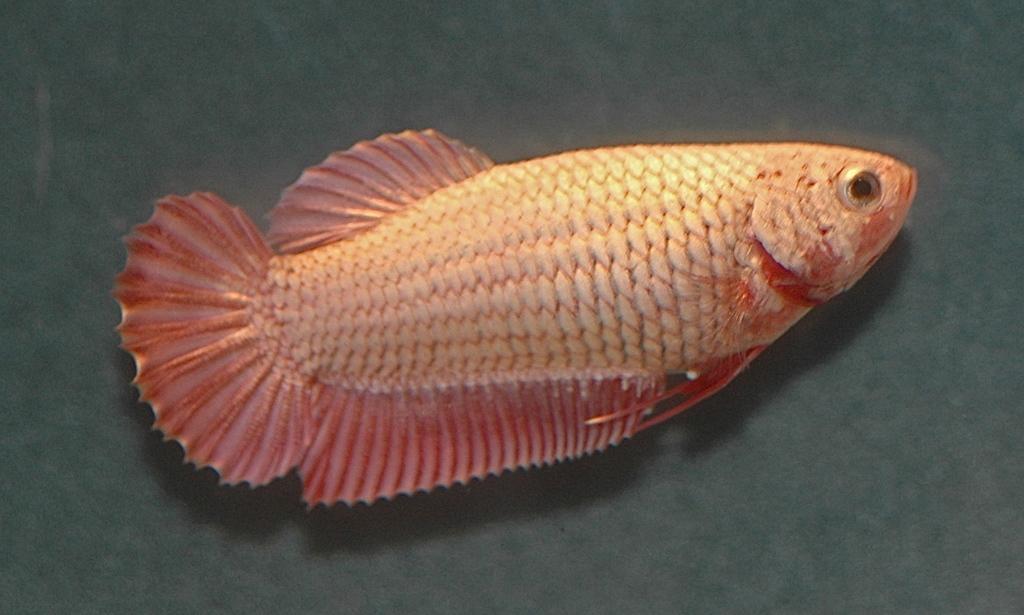In one or two sentences, can you explain what this image depicts? In this image I can see a pink and cream colour fish. 